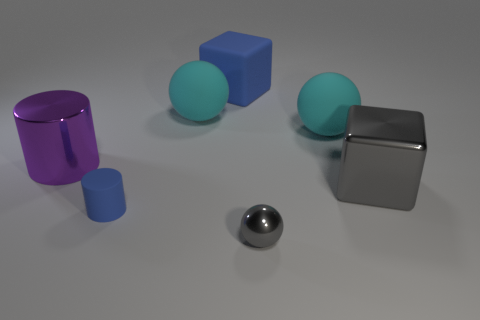There is a large block that is behind the purple cylinder; is its color the same as the cylinder in front of the purple shiny cylinder?
Make the answer very short. Yes. The other rubber thing that is the same shape as the large purple thing is what size?
Offer a terse response. Small. Are there any cyan matte spheres on the right side of the small blue rubber cylinder?
Your answer should be very brief. Yes. Are there an equal number of large purple shiny objects to the left of the purple shiny cylinder and small red rubber things?
Ensure brevity in your answer.  Yes. There is a large cyan ball that is behind the large cyan object that is to the right of the blue rubber cube; are there any tiny gray metal things in front of it?
Provide a succinct answer. Yes. What is the large blue block made of?
Make the answer very short. Rubber. How many other things are the same shape as the big blue thing?
Make the answer very short. 1. Is the shape of the small rubber object the same as the large purple metallic object?
Keep it short and to the point. Yes. How many things are either cylinders that are in front of the large purple cylinder or cylinders in front of the purple cylinder?
Keep it short and to the point. 1. What number of objects are big purple things or big blocks?
Keep it short and to the point. 3. 